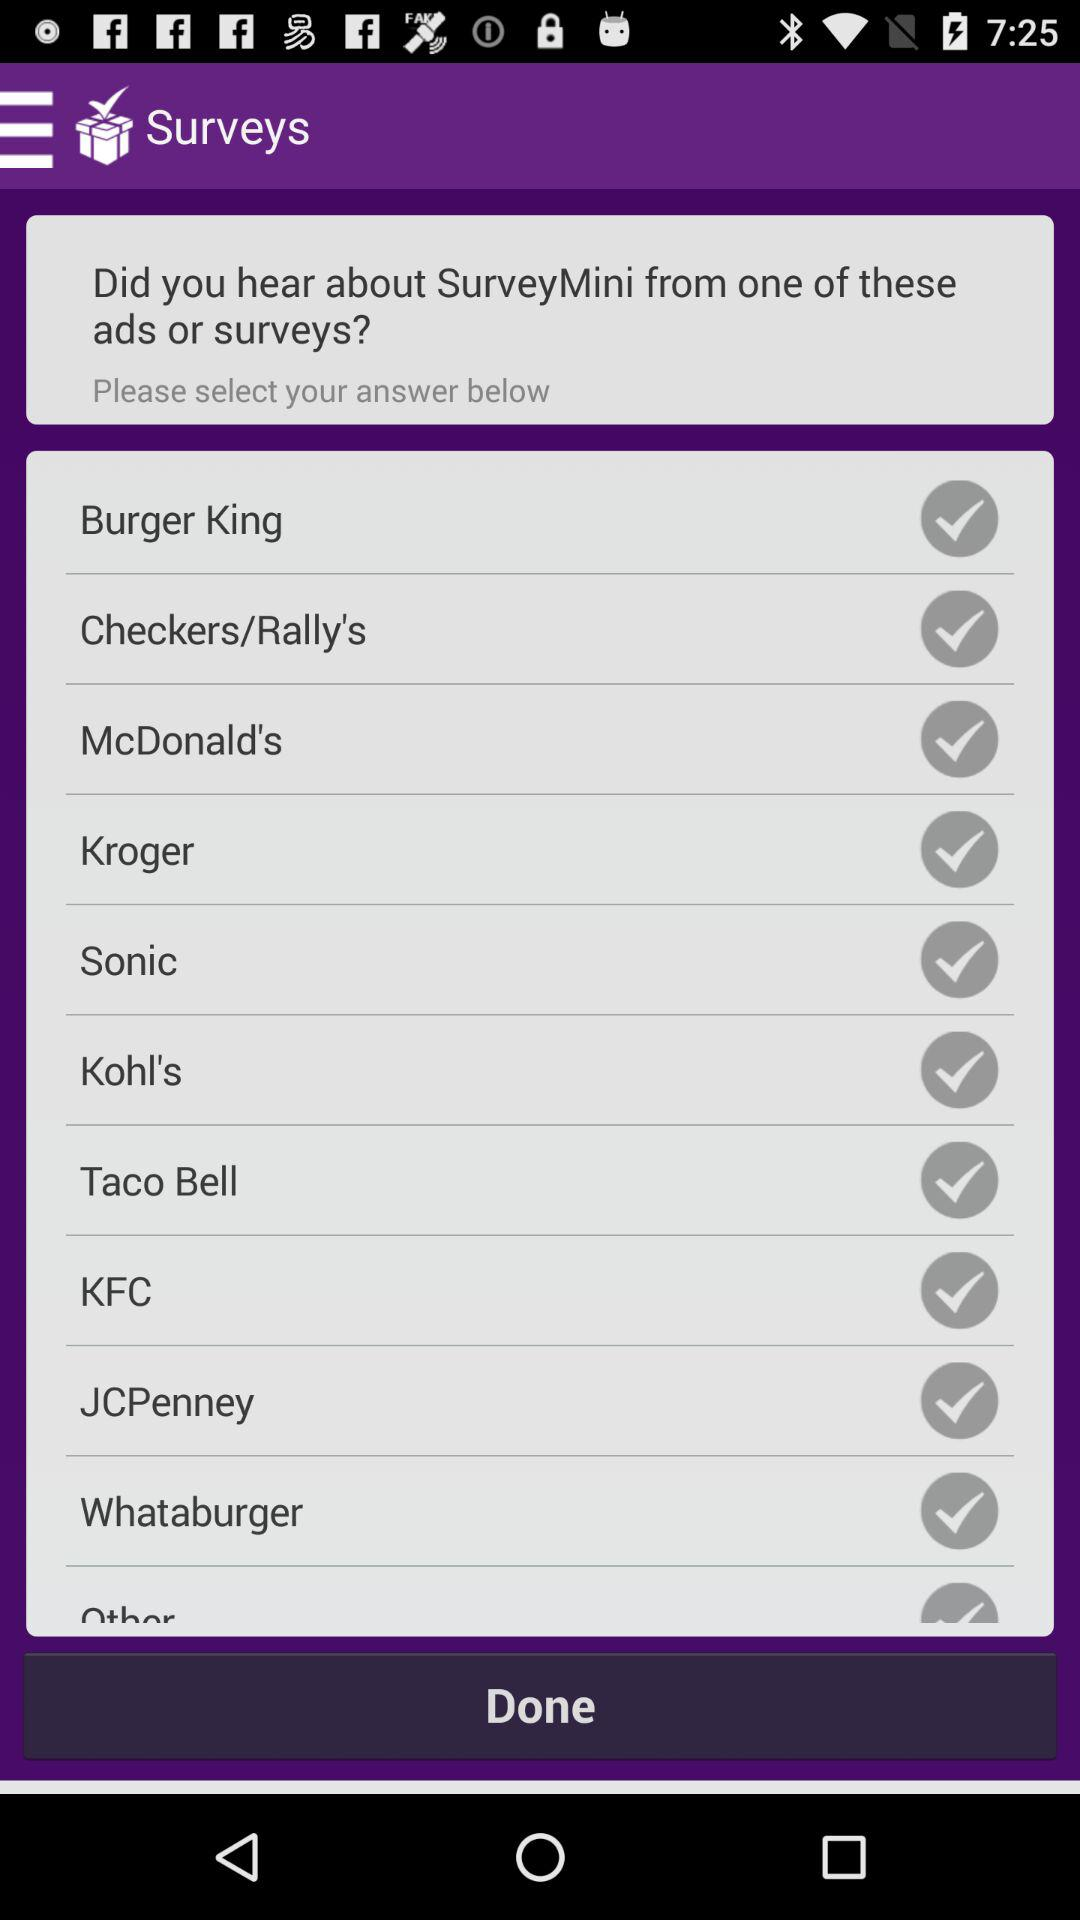How many brands are available for selection?
Answer the question using a single word or phrase. 10 